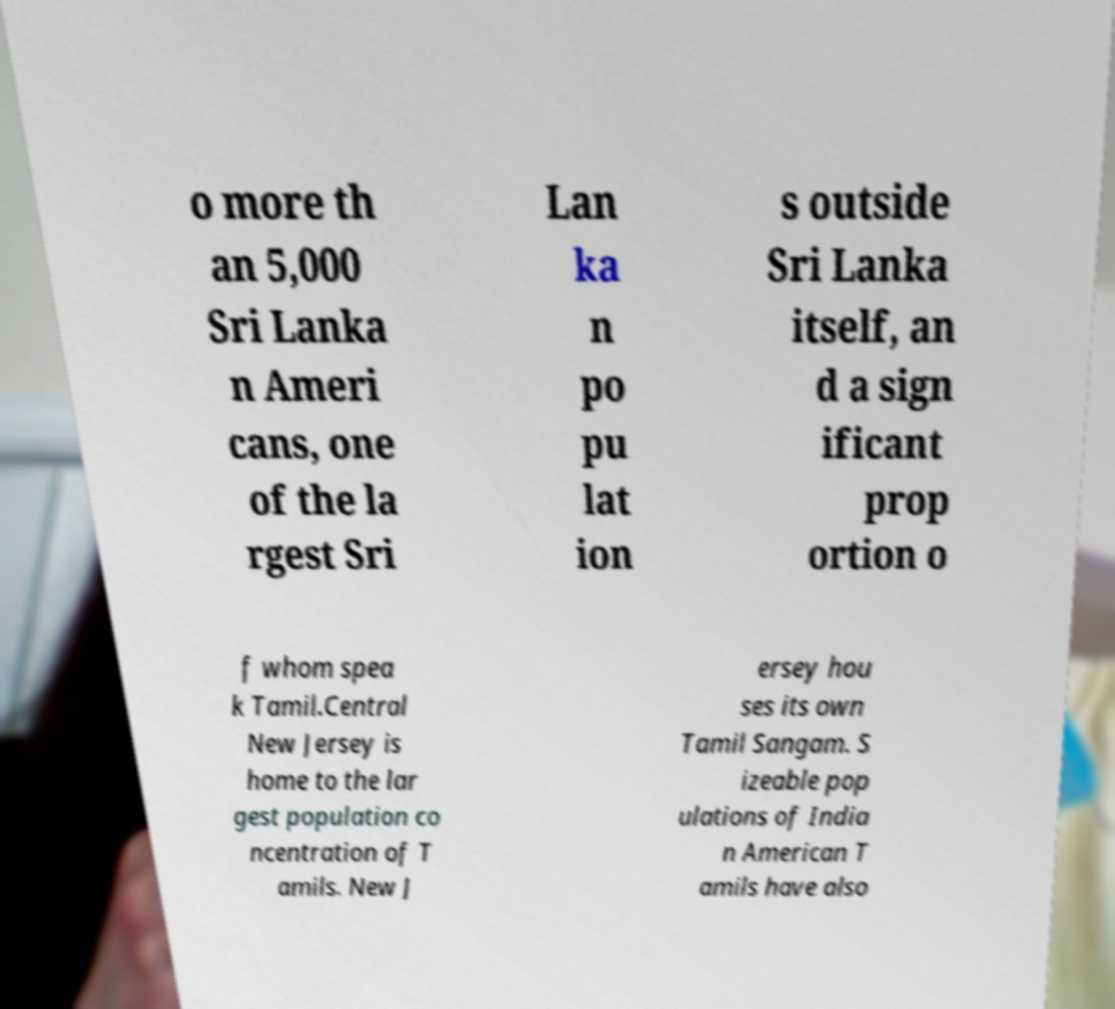Please read and relay the text visible in this image. What does it say? o more th an 5,000 Sri Lanka n Ameri cans, one of the la rgest Sri Lan ka n po pu lat ion s outside Sri Lanka itself, an d a sign ificant prop ortion o f whom spea k Tamil.Central New Jersey is home to the lar gest population co ncentration of T amils. New J ersey hou ses its own Tamil Sangam. S izeable pop ulations of India n American T amils have also 